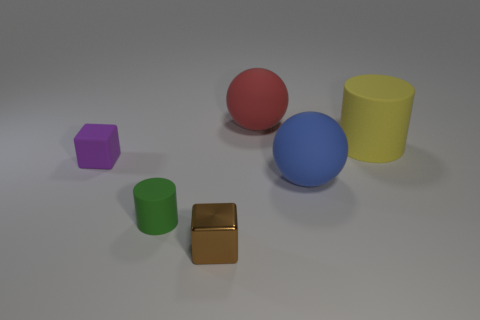What is the material of the thing behind the rubber cylinder right of the matte sphere behind the purple rubber block?
Ensure brevity in your answer.  Rubber. What number of small things are either metal things or red things?
Provide a short and direct response. 1. What number of other things are the same size as the blue ball?
Ensure brevity in your answer.  2. There is a small matte object that is to the right of the small purple matte cube; is its shape the same as the tiny metallic thing?
Provide a succinct answer. No. What is the color of the other thing that is the same shape as the purple object?
Your answer should be very brief. Brown. Is there anything else that is the same shape as the red rubber thing?
Your response must be concise. Yes. Are there an equal number of matte things right of the tiny green rubber cylinder and red cylinders?
Offer a terse response. No. How many objects are to the right of the green rubber cylinder and in front of the big blue matte sphere?
Your answer should be very brief. 1. The purple matte thing that is the same shape as the brown shiny thing is what size?
Provide a short and direct response. Small. How many purple objects are made of the same material as the small cylinder?
Make the answer very short. 1. 